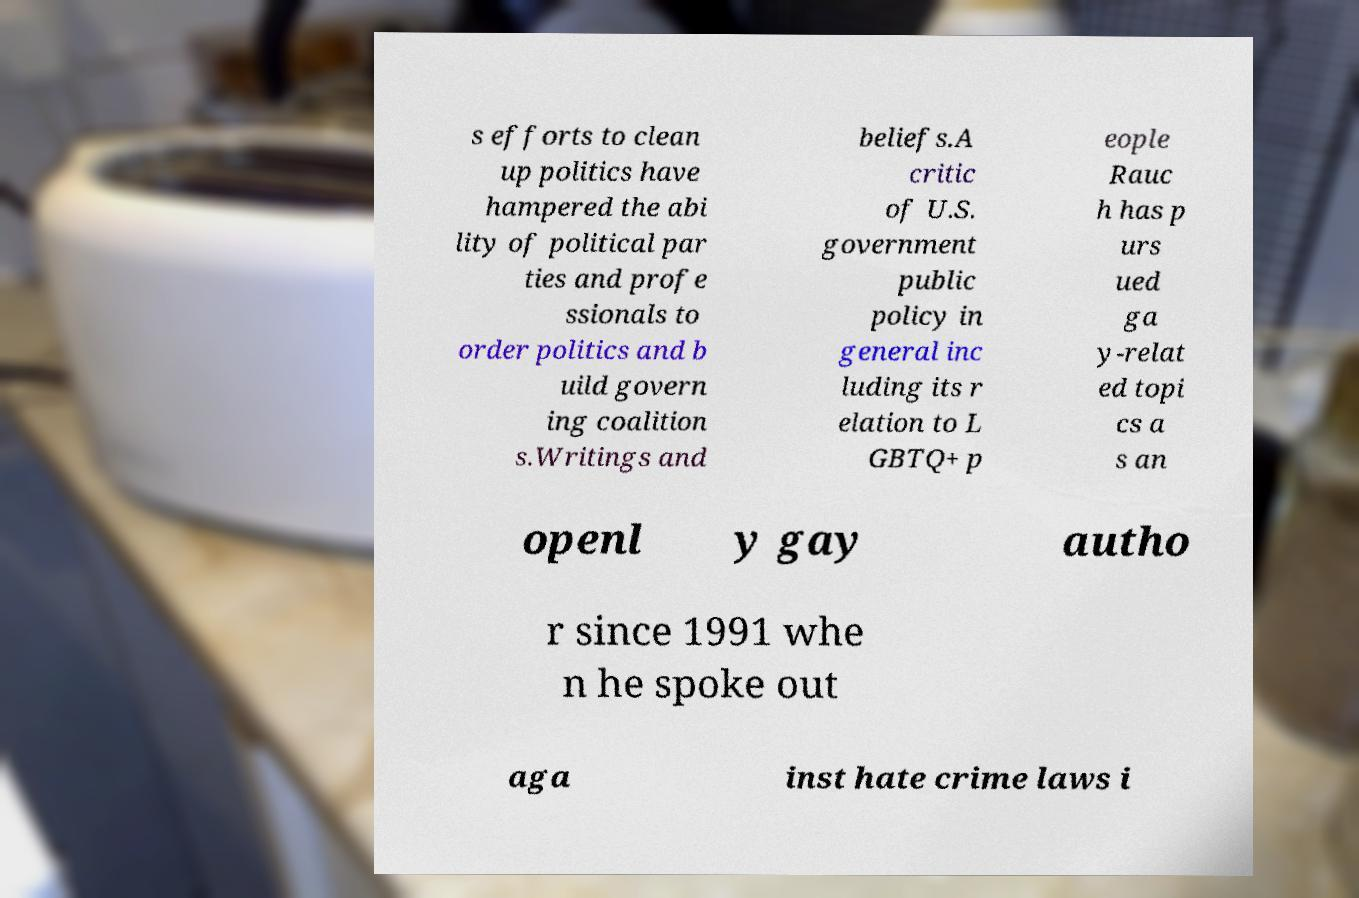Could you extract and type out the text from this image? s efforts to clean up politics have hampered the abi lity of political par ties and profe ssionals to order politics and b uild govern ing coalition s.Writings and beliefs.A critic of U.S. government public policy in general inc luding its r elation to L GBTQ+ p eople Rauc h has p urs ued ga y-relat ed topi cs a s an openl y gay autho r since 1991 whe n he spoke out aga inst hate crime laws i 